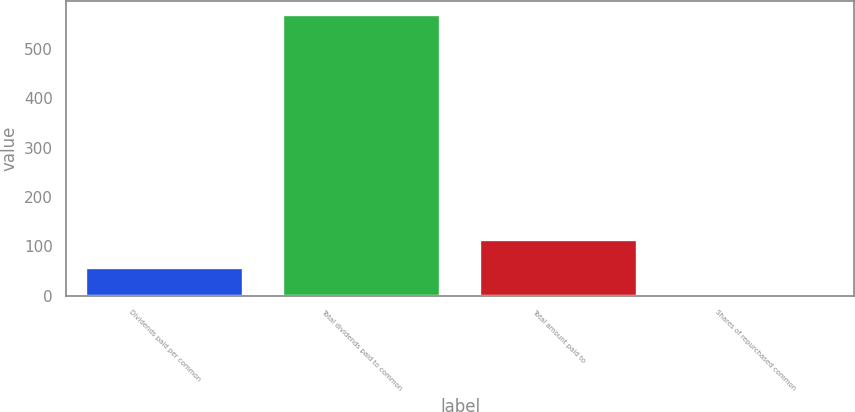<chart> <loc_0><loc_0><loc_500><loc_500><bar_chart><fcel>Dividends paid per common<fcel>Total dividends paid to common<fcel>Total amount paid to<fcel>Shares of repurchased common<nl><fcel>56.89<fcel>568<fcel>113.68<fcel>0.1<nl></chart> 